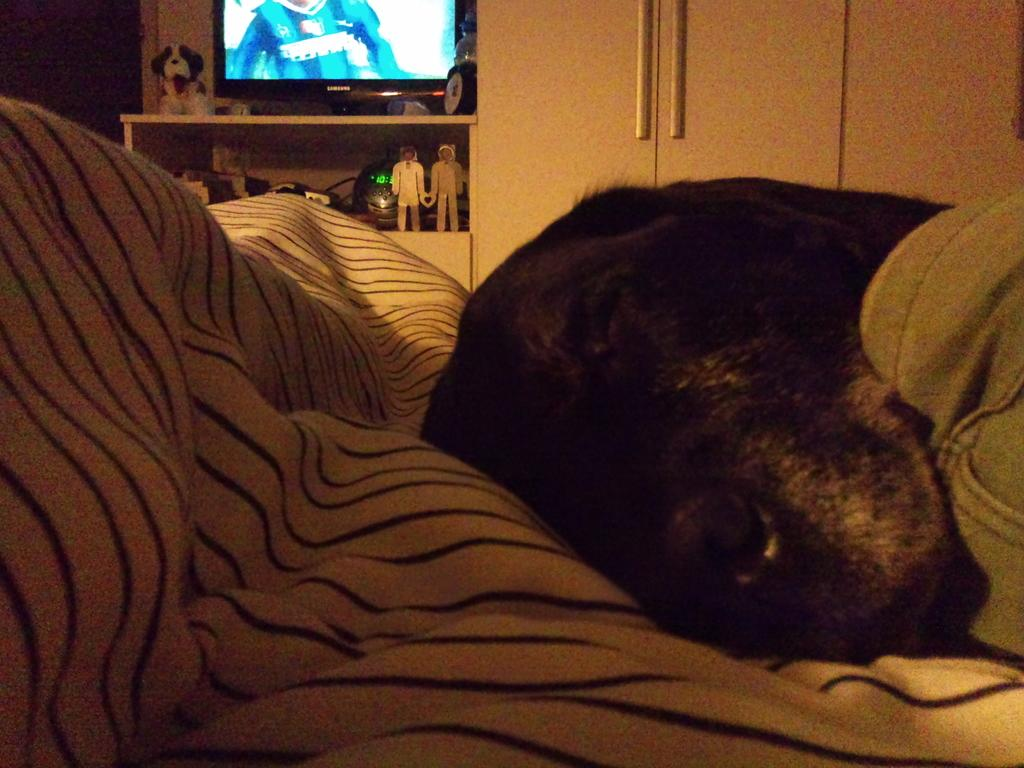Where is the setting of the image? The image is inside a room. What can be seen on the bed in the image? There is a dog lying on the bed in the image. What is visible in the background of the image? There is a table, a toy dog, a wall, and a shelf in the background of the image. Can you describe the color of the shelf in the image? The shelf in the background of the image is in cream color. What type of produce is being sold on the shelf in the image? There is no produce visible in the image; the shelf is in cream color and does not contain any items for sale. 